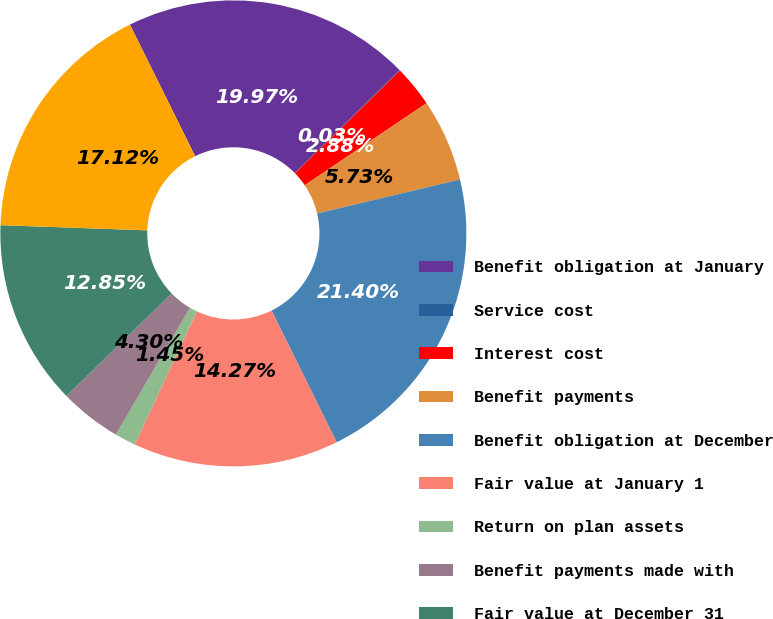Convert chart to OTSL. <chart><loc_0><loc_0><loc_500><loc_500><pie_chart><fcel>Benefit obligation at January<fcel>Service cost<fcel>Interest cost<fcel>Benefit payments<fcel>Benefit obligation at December<fcel>Fair value at January 1<fcel>Return on plan assets<fcel>Benefit payments made with<fcel>Fair value at December 31<fcel>Funded status of the plan<nl><fcel>19.97%<fcel>0.03%<fcel>2.88%<fcel>5.73%<fcel>21.4%<fcel>14.27%<fcel>1.45%<fcel>4.3%<fcel>12.85%<fcel>17.12%<nl></chart> 